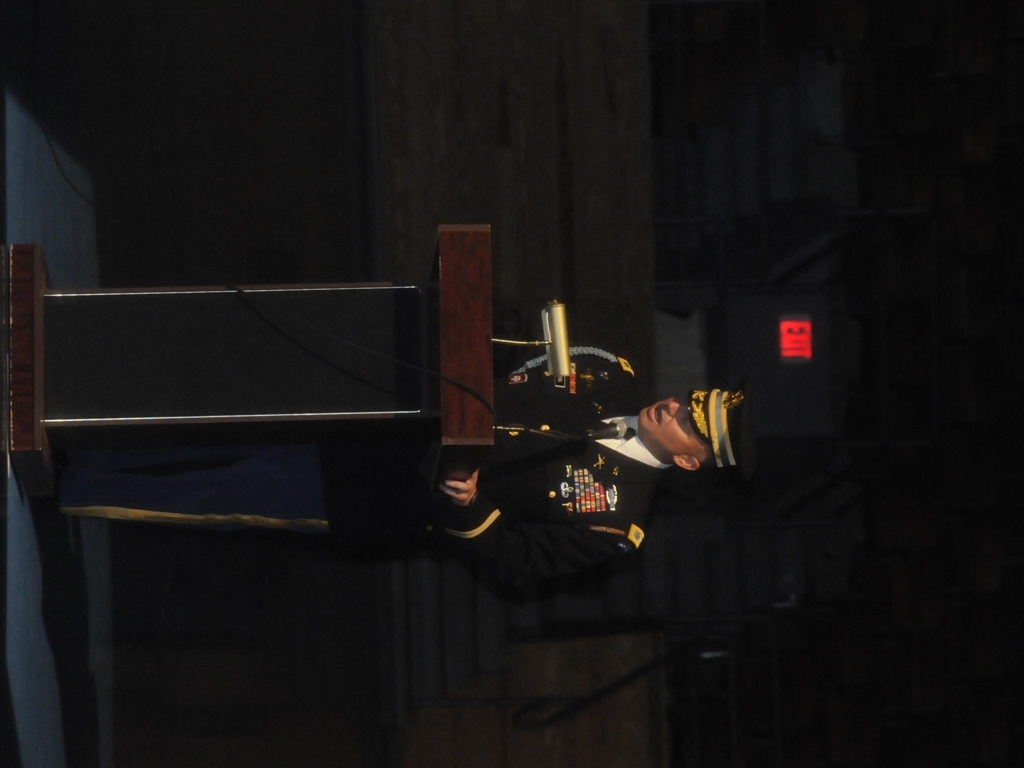Can you describe the attire of the individual speaking at the podium? The individual is wearing a formal military uniform with medals and insignia, indicating a person of significant rank and experience. 